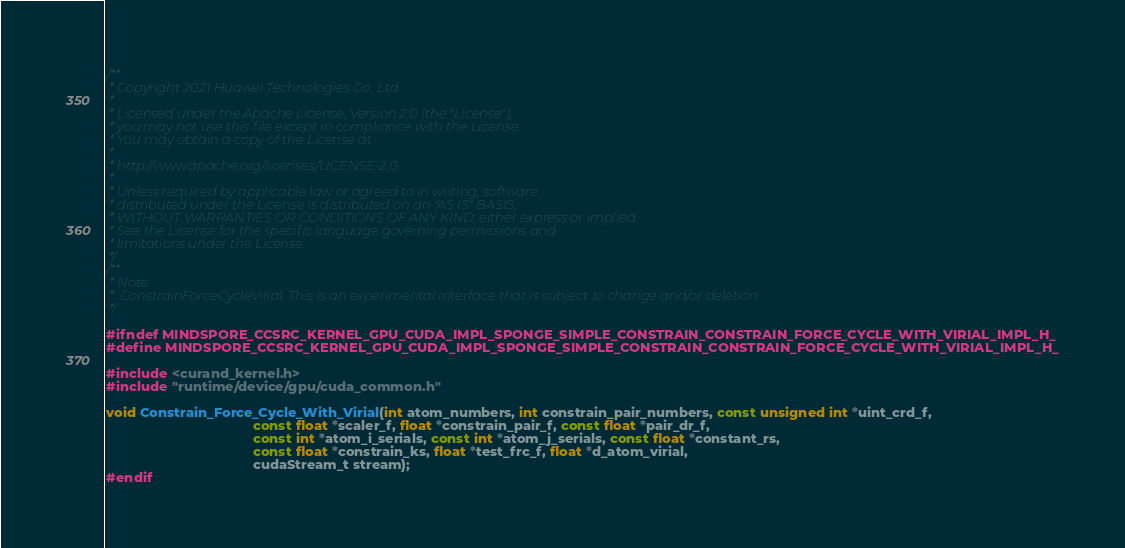Convert code to text. <code><loc_0><loc_0><loc_500><loc_500><_Cuda_>/**
 * Copyright 2021 Huawei Technologies Co., Ltd
 *
 * Licensed under the Apache License, Version 2.0 (the "License");
 * you may not use this file except in compliance with the License.
 * You may obtain a copy of the License at
 *
 * http://www.apache.org/licenses/LICENSE-2.0
 *
 * Unless required by applicable law or agreed to in writing, software
 * distributed under the License is distributed on an "AS IS" BASIS,
 * WITHOUT WARRANTIES OR CONDITIONS OF ANY KIND, either express or implied.
 * See the License for the specific language governing permissions and
 * limitations under the License.
 */
/**
 * Note:
 *  ConstrainForceCycleVirial. This is an experimental interface that is subject to change and/or deletion.
 */

#ifndef MINDSPORE_CCSRC_KERNEL_GPU_CUDA_IMPL_SPONGE_SIMPLE_CONSTRAIN_CONSTRAIN_FORCE_CYCLE_WITH_VIRIAL_IMPL_H_
#define MINDSPORE_CCSRC_KERNEL_GPU_CUDA_IMPL_SPONGE_SIMPLE_CONSTRAIN_CONSTRAIN_FORCE_CYCLE_WITH_VIRIAL_IMPL_H_

#include <curand_kernel.h>
#include "runtime/device/gpu/cuda_common.h"

void Constrain_Force_Cycle_With_Virial(int atom_numbers, int constrain_pair_numbers, const unsigned int *uint_crd_f,
                                       const float *scaler_f, float *constrain_pair_f, const float *pair_dr_f,
                                       const int *atom_i_serials, const int *atom_j_serials, const float *constant_rs,
                                       const float *constrain_ks, float *test_frc_f, float *d_atom_virial,
                                       cudaStream_t stream);
#endif
</code> 